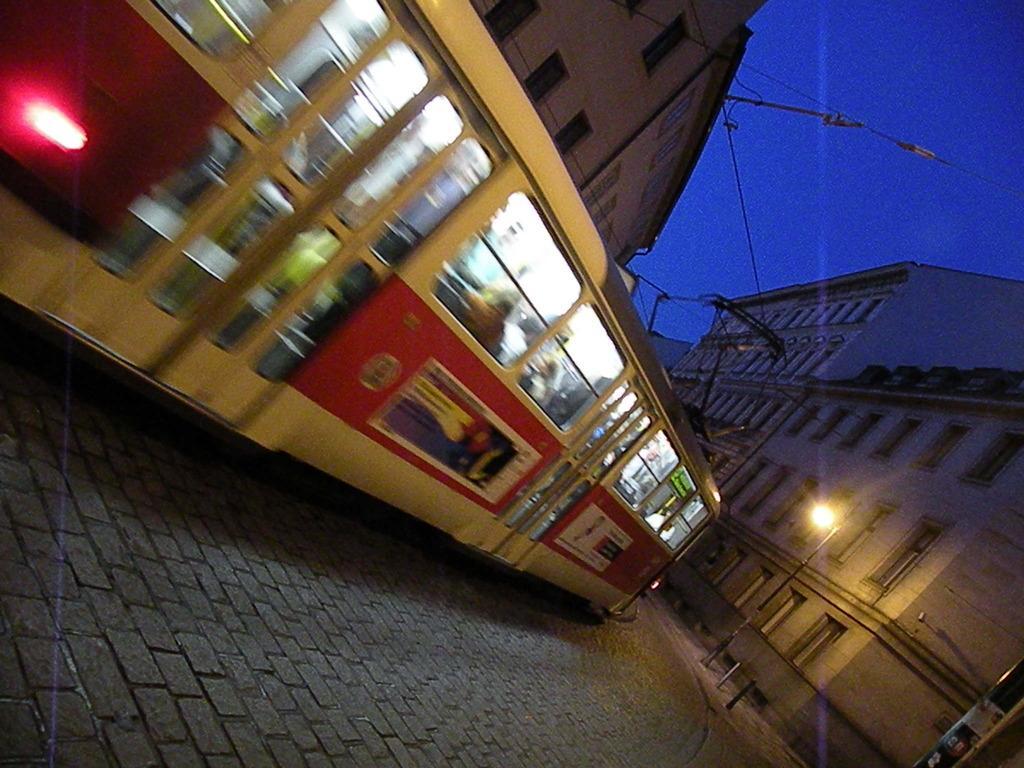Describe this image in one or two sentences. In this image I can see a tram and in it I can see number of people. I can also see few buildings, a pole, a light, few wires and the sky. 